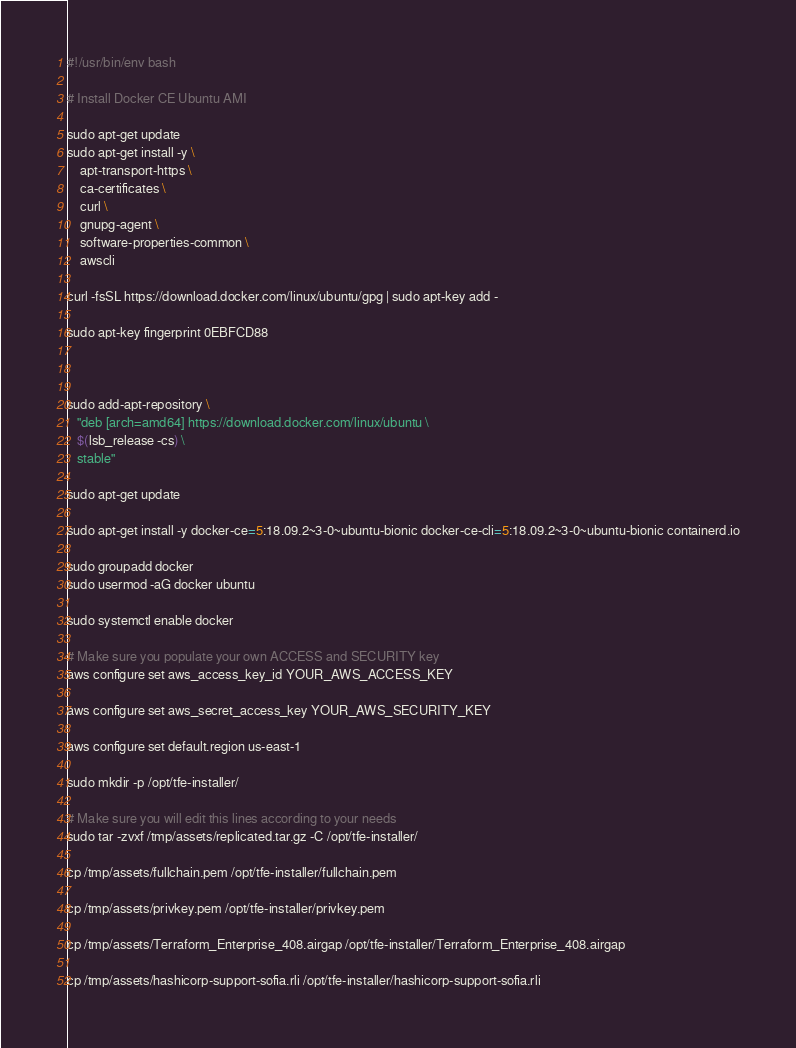Convert code to text. <code><loc_0><loc_0><loc_500><loc_500><_Bash_>#!/usr/bin/env bash

# Install Docker CE Ubuntu AMI

sudo apt-get update
sudo apt-get install -y \
    apt-transport-https \
    ca-certificates \
    curl \
    gnupg-agent \
    software-properties-common \
    awscli

curl -fsSL https://download.docker.com/linux/ubuntu/gpg | sudo apt-key add -

sudo apt-key fingerprint 0EBFCD88



sudo add-apt-repository \
   "deb [arch=amd64] https://download.docker.com/linux/ubuntu \
   $(lsb_release -cs) \
   stable"

sudo apt-get update

sudo apt-get install -y docker-ce=5:18.09.2~3-0~ubuntu-bionic docker-ce-cli=5:18.09.2~3-0~ubuntu-bionic containerd.io

sudo groupadd docker
sudo usermod -aG docker ubuntu

sudo systemctl enable docker

# Make sure you populate your own ACCESS and SECURITY key
aws configure set aws_access_key_id YOUR_AWS_ACCESS_KEY

aws configure set aws_secret_access_key YOUR_AWS_SECURITY_KEY

aws configure set default.region us-east-1

sudo mkdir -p /opt/tfe-installer/

# Make sure you will edit this lines according to your needs
sudo tar -zvxf /tmp/assets/replicated.tar.gz -C /opt/tfe-installer/

cp /tmp/assets/fullchain.pem /opt/tfe-installer/fullchain.pem

cp /tmp/assets/privkey.pem /opt/tfe-installer/privkey.pem

cp /tmp/assets/Terraform_Enterprise_408.airgap /opt/tfe-installer/Terraform_Enterprise_408.airgap

cp /tmp/assets/hashicorp-support-sofia.rli /opt/tfe-installer/hashicorp-support-sofia.rli
</code> 